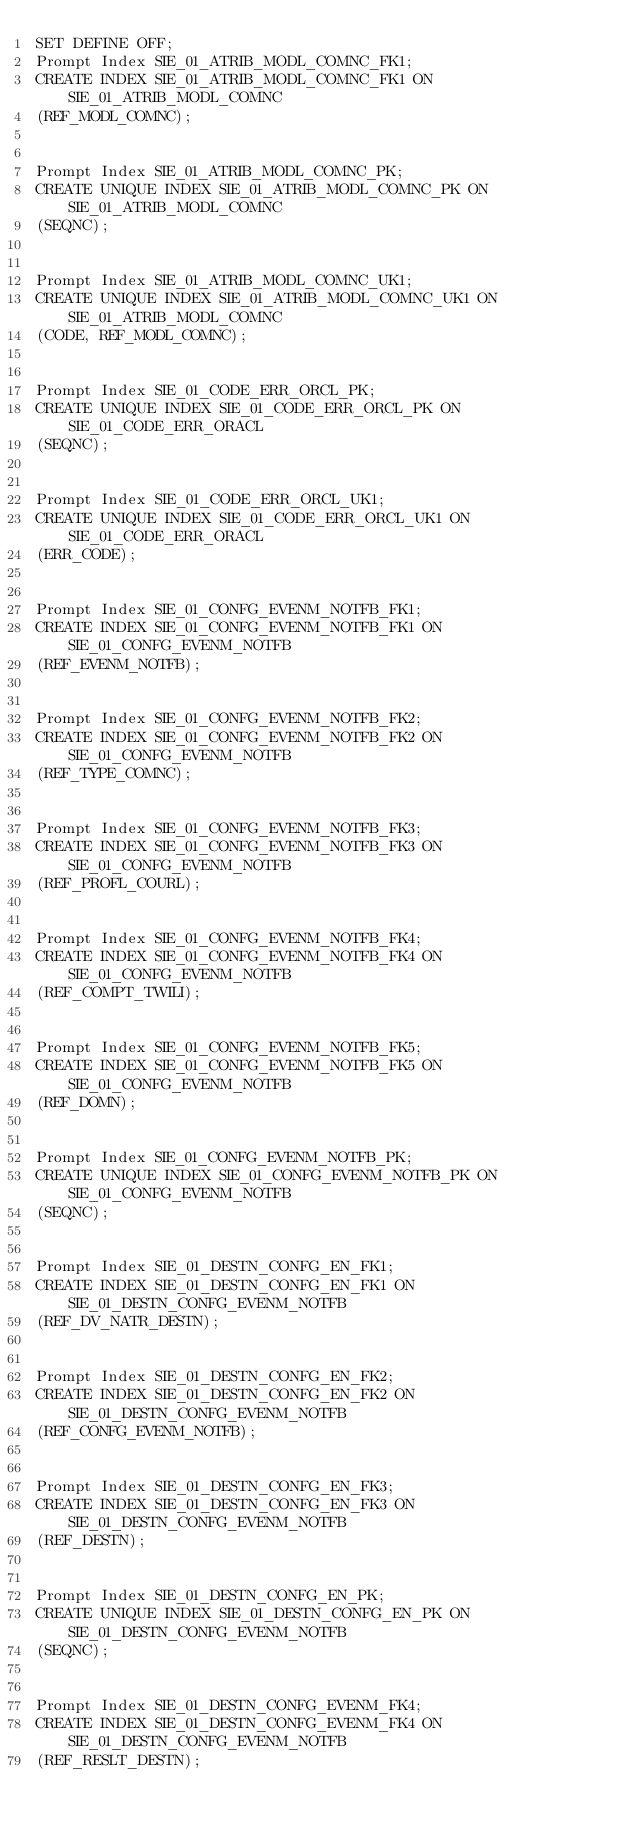<code> <loc_0><loc_0><loc_500><loc_500><_SQL_>SET DEFINE OFF;
Prompt Index SIE_01_ATRIB_MODL_COMNC_FK1;
CREATE INDEX SIE_01_ATRIB_MODL_COMNC_FK1 ON SIE_01_ATRIB_MODL_COMNC
(REF_MODL_COMNC);


Prompt Index SIE_01_ATRIB_MODL_COMNC_PK;
CREATE UNIQUE INDEX SIE_01_ATRIB_MODL_COMNC_PK ON SIE_01_ATRIB_MODL_COMNC
(SEQNC);


Prompt Index SIE_01_ATRIB_MODL_COMNC_UK1;
CREATE UNIQUE INDEX SIE_01_ATRIB_MODL_COMNC_UK1 ON SIE_01_ATRIB_MODL_COMNC
(CODE, REF_MODL_COMNC);


Prompt Index SIE_01_CODE_ERR_ORCL_PK;
CREATE UNIQUE INDEX SIE_01_CODE_ERR_ORCL_PK ON SIE_01_CODE_ERR_ORACL
(SEQNC);


Prompt Index SIE_01_CODE_ERR_ORCL_UK1;
CREATE UNIQUE INDEX SIE_01_CODE_ERR_ORCL_UK1 ON SIE_01_CODE_ERR_ORACL
(ERR_CODE);


Prompt Index SIE_01_CONFG_EVENM_NOTFB_FK1;
CREATE INDEX SIE_01_CONFG_EVENM_NOTFB_FK1 ON SIE_01_CONFG_EVENM_NOTFB
(REF_EVENM_NOTFB);


Prompt Index SIE_01_CONFG_EVENM_NOTFB_FK2;
CREATE INDEX SIE_01_CONFG_EVENM_NOTFB_FK2 ON SIE_01_CONFG_EVENM_NOTFB
(REF_TYPE_COMNC);


Prompt Index SIE_01_CONFG_EVENM_NOTFB_FK3;
CREATE INDEX SIE_01_CONFG_EVENM_NOTFB_FK3 ON SIE_01_CONFG_EVENM_NOTFB
(REF_PROFL_COURL);


Prompt Index SIE_01_CONFG_EVENM_NOTFB_FK4;
CREATE INDEX SIE_01_CONFG_EVENM_NOTFB_FK4 ON SIE_01_CONFG_EVENM_NOTFB
(REF_COMPT_TWILI);


Prompt Index SIE_01_CONFG_EVENM_NOTFB_FK5;
CREATE INDEX SIE_01_CONFG_EVENM_NOTFB_FK5 ON SIE_01_CONFG_EVENM_NOTFB
(REF_DOMN);


Prompt Index SIE_01_CONFG_EVENM_NOTFB_PK;
CREATE UNIQUE INDEX SIE_01_CONFG_EVENM_NOTFB_PK ON SIE_01_CONFG_EVENM_NOTFB
(SEQNC);


Prompt Index SIE_01_DESTN_CONFG_EN_FK1;
CREATE INDEX SIE_01_DESTN_CONFG_EN_FK1 ON SIE_01_DESTN_CONFG_EVENM_NOTFB
(REF_DV_NATR_DESTN);


Prompt Index SIE_01_DESTN_CONFG_EN_FK2;
CREATE INDEX SIE_01_DESTN_CONFG_EN_FK2 ON SIE_01_DESTN_CONFG_EVENM_NOTFB
(REF_CONFG_EVENM_NOTFB);


Prompt Index SIE_01_DESTN_CONFG_EN_FK3;
CREATE INDEX SIE_01_DESTN_CONFG_EN_FK3 ON SIE_01_DESTN_CONFG_EVENM_NOTFB
(REF_DESTN);


Prompt Index SIE_01_DESTN_CONFG_EN_PK;
CREATE UNIQUE INDEX SIE_01_DESTN_CONFG_EN_PK ON SIE_01_DESTN_CONFG_EVENM_NOTFB
(SEQNC);


Prompt Index SIE_01_DESTN_CONFG_EVENM_FK4;
CREATE INDEX SIE_01_DESTN_CONFG_EVENM_FK4 ON SIE_01_DESTN_CONFG_EVENM_NOTFB
(REF_RESLT_DESTN);

</code> 